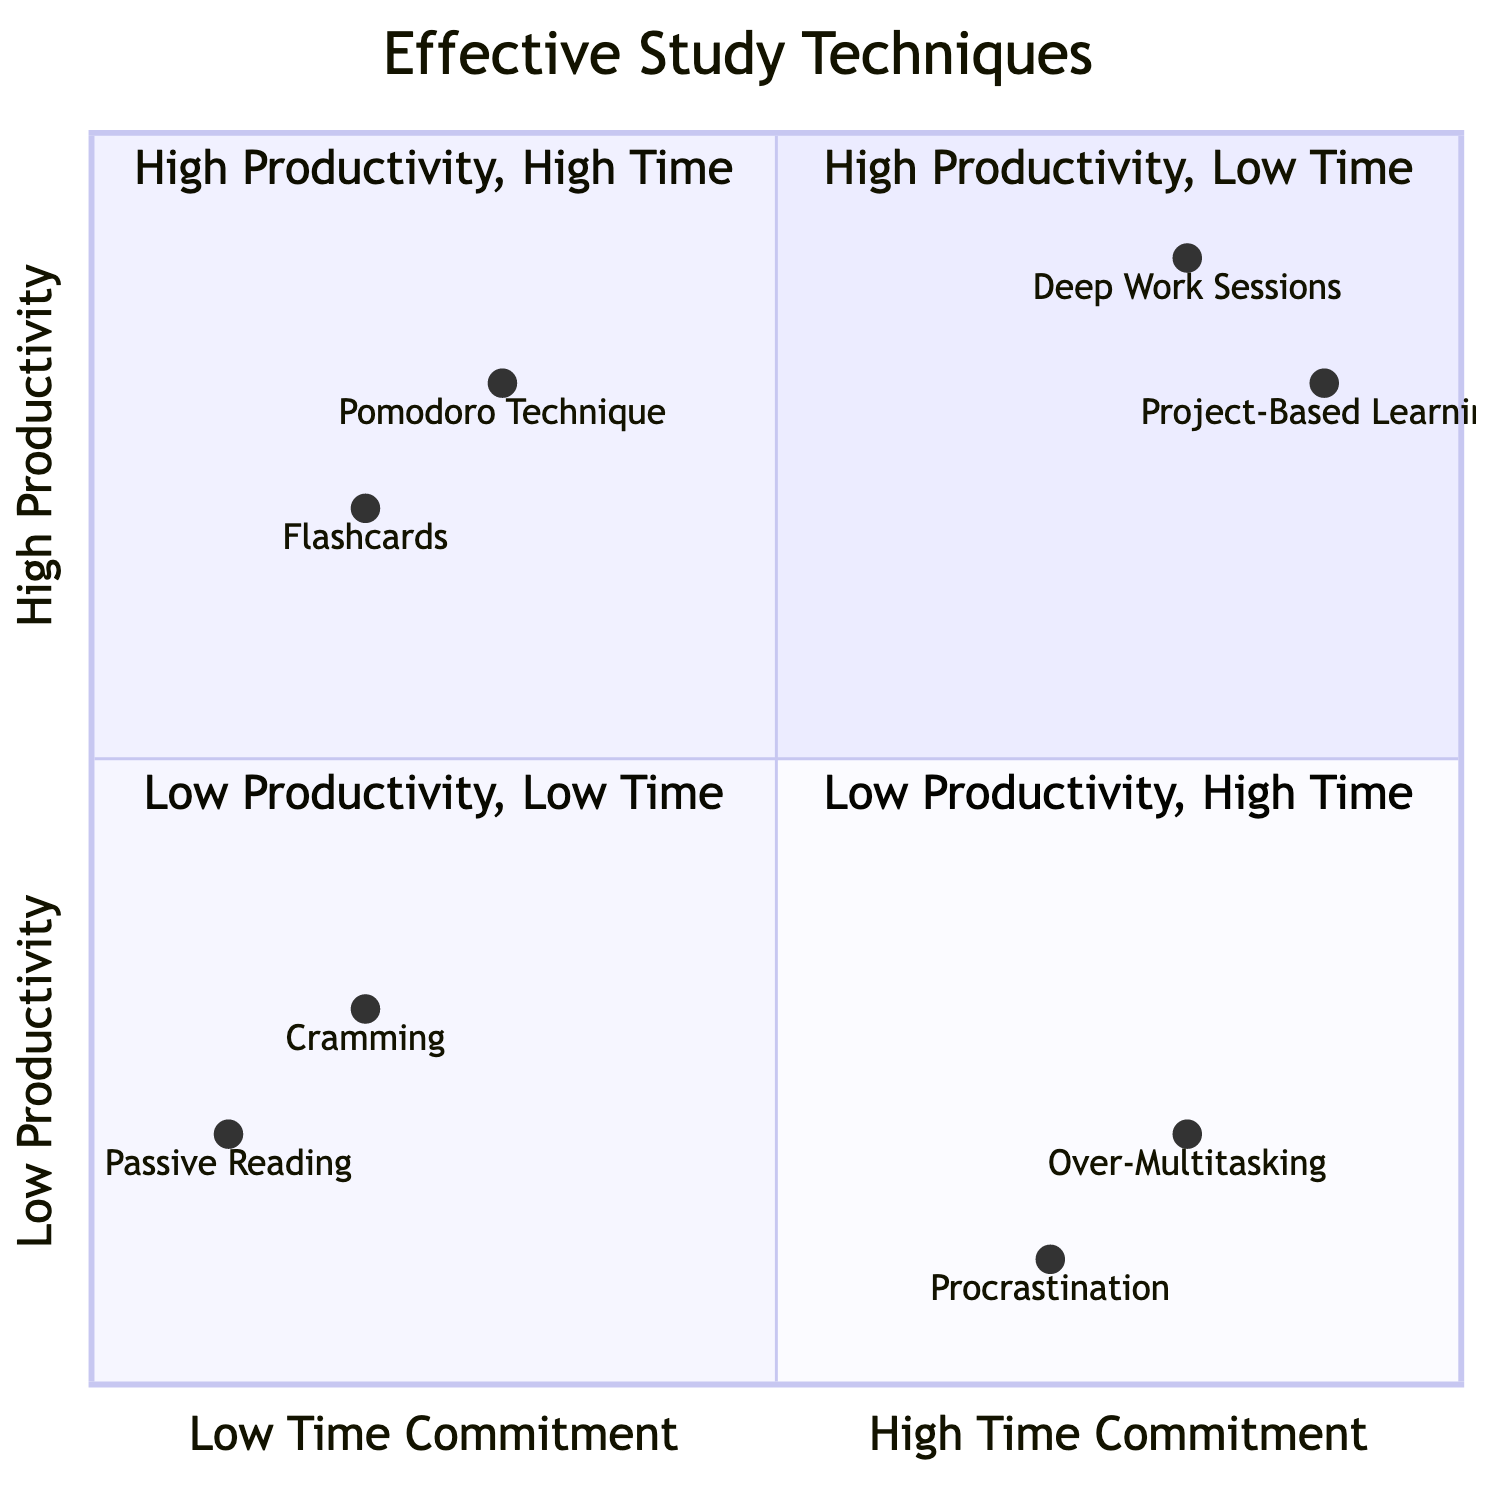What are the two techniques in the High Productivity, Low Time Commitment quadrant? Referring to the quadrant labeled "High Productivity, Low Time Commitment," the two listed techniques are "Pomodoro Technique" and "Flashcards."
Answer: Pomodoro Technique, Flashcards Which technique has the highest productivity but also requires a high time commitment? In the quadrant "High Productivity, High Time Commitment," the technique that stands out with the highest productivity rating is "Project-Based Learning," which appears prominently in this section of the chart.
Answer: Project-Based Learning How many techniques are in the Low Productivity, Low Time Commitment quadrant? By analyzing the "Low Productivity, Low Time Commitment" quadrant, I see that there are two listed techniques: "Cramming" and "Passive Reading."
Answer: 2 What is the productivity rating of "Deep Work Sessions"? The data points for "Deep Work Sessions" indicate a productivity rating of 0.9, which is located in the "High Productivity, High Time Commitment" quadrant.
Answer: 0.9 What is the relationship between "Procrastination" and "Over-Multitasking"? Both "Procrastination" and "Over-Multitasking" are located in the same quadrant titled "Low Productivity, High Time Commitment." This signifies that both techniques exhibit low productivity despite requiring a significant amount of time.
Answer: Same quadrant Which study technique is associated with the lowest productivity rating? Upon examining the quadrants, "Passive Reading" has the lowest productivity rating at 0.2, positioning it in the "Low Productivity, Low Time Commitment" quadrant.
Answer: Passive Reading What does the x-axis of the diagram represent? The x-axis in the quadrant chart is labeled with "Low Time Commitment" to "High Time Commitment," indicating the range of time commitment for the study techniques shown.
Answer: Time Commitment How does the Pomodoro Technique compare to Flashcards in terms of time commitment? Both the "Pomodoro Technique" and "Flashcards" are positioned in the quadrant marked "High Productivity, Low Time Commitment," suggesting that both require a relatively low amount of time for a high level of productivity.
Answer: Same quadrant 